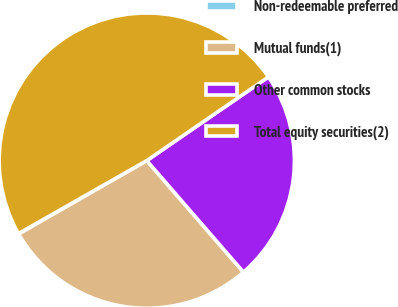<chart> <loc_0><loc_0><loc_500><loc_500><pie_chart><fcel>Non-redeemable preferred<fcel>Mutual funds(1)<fcel>Other common stocks<fcel>Total equity securities(2)<nl><fcel>0.05%<fcel>28.08%<fcel>23.22%<fcel>48.64%<nl></chart> 